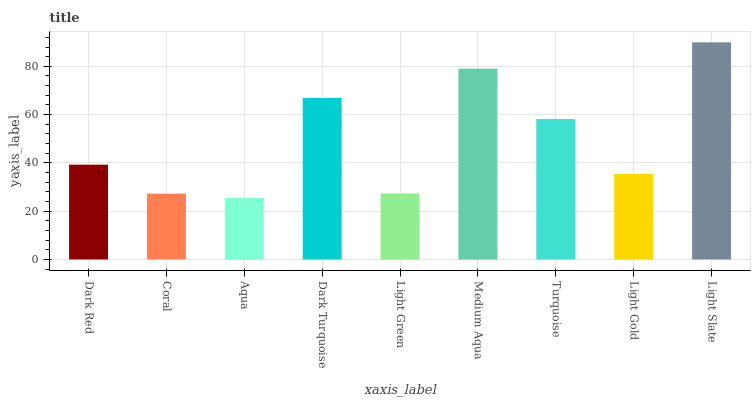Is Aqua the minimum?
Answer yes or no. Yes. Is Light Slate the maximum?
Answer yes or no. Yes. Is Coral the minimum?
Answer yes or no. No. Is Coral the maximum?
Answer yes or no. No. Is Dark Red greater than Coral?
Answer yes or no. Yes. Is Coral less than Dark Red?
Answer yes or no. Yes. Is Coral greater than Dark Red?
Answer yes or no. No. Is Dark Red less than Coral?
Answer yes or no. No. Is Dark Red the high median?
Answer yes or no. Yes. Is Dark Red the low median?
Answer yes or no. Yes. Is Dark Turquoise the high median?
Answer yes or no. No. Is Coral the low median?
Answer yes or no. No. 